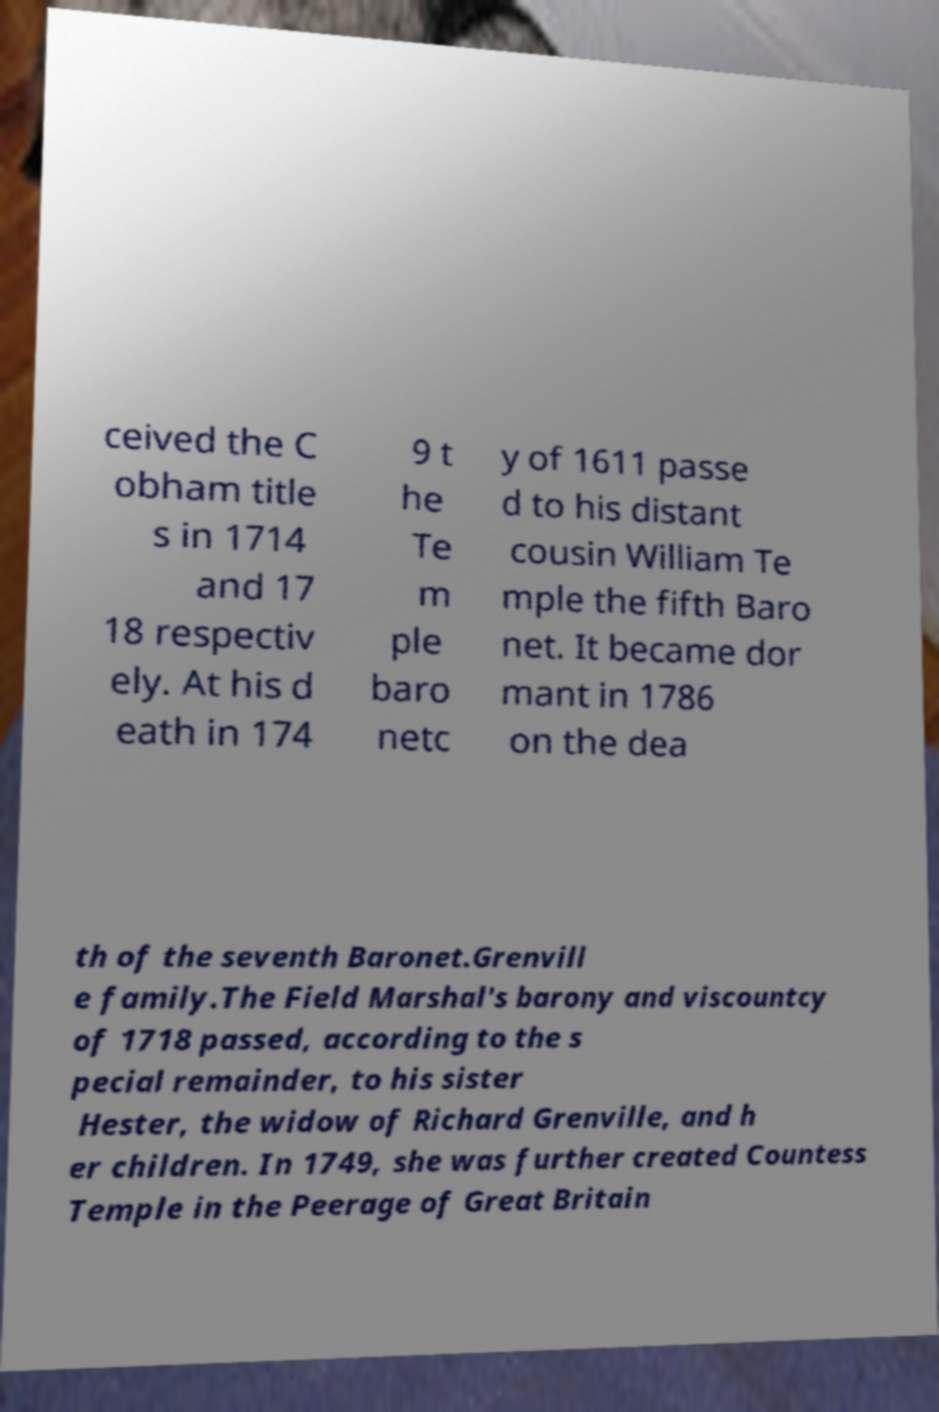Could you assist in decoding the text presented in this image and type it out clearly? ceived the C obham title s in 1714 and 17 18 respectiv ely. At his d eath in 174 9 t he Te m ple baro netc y of 1611 passe d to his distant cousin William Te mple the fifth Baro net. It became dor mant in 1786 on the dea th of the seventh Baronet.Grenvill e family.The Field Marshal's barony and viscountcy of 1718 passed, according to the s pecial remainder, to his sister Hester, the widow of Richard Grenville, and h er children. In 1749, she was further created Countess Temple in the Peerage of Great Britain 